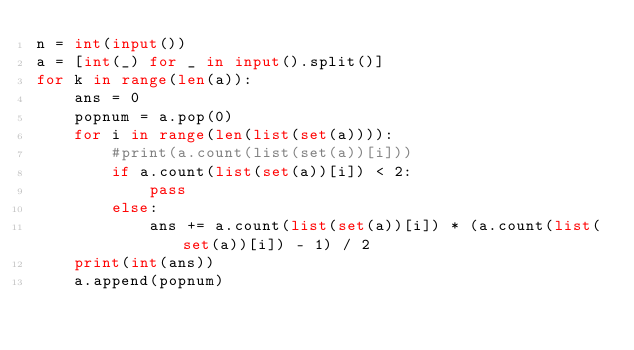Convert code to text. <code><loc_0><loc_0><loc_500><loc_500><_Python_>n = int(input())
a = [int(_) for _ in input().split()]
for k in range(len(a)):
    ans = 0
    popnum = a.pop(0)
    for i in range(len(list(set(a)))):
        #print(a.count(list(set(a))[i]))
        if a.count(list(set(a))[i]) < 2:
            pass
        else:
            ans += a.count(list(set(a))[i]) * (a.count(list(set(a))[i]) - 1) / 2
    print(int(ans))
    a.append(popnum)</code> 